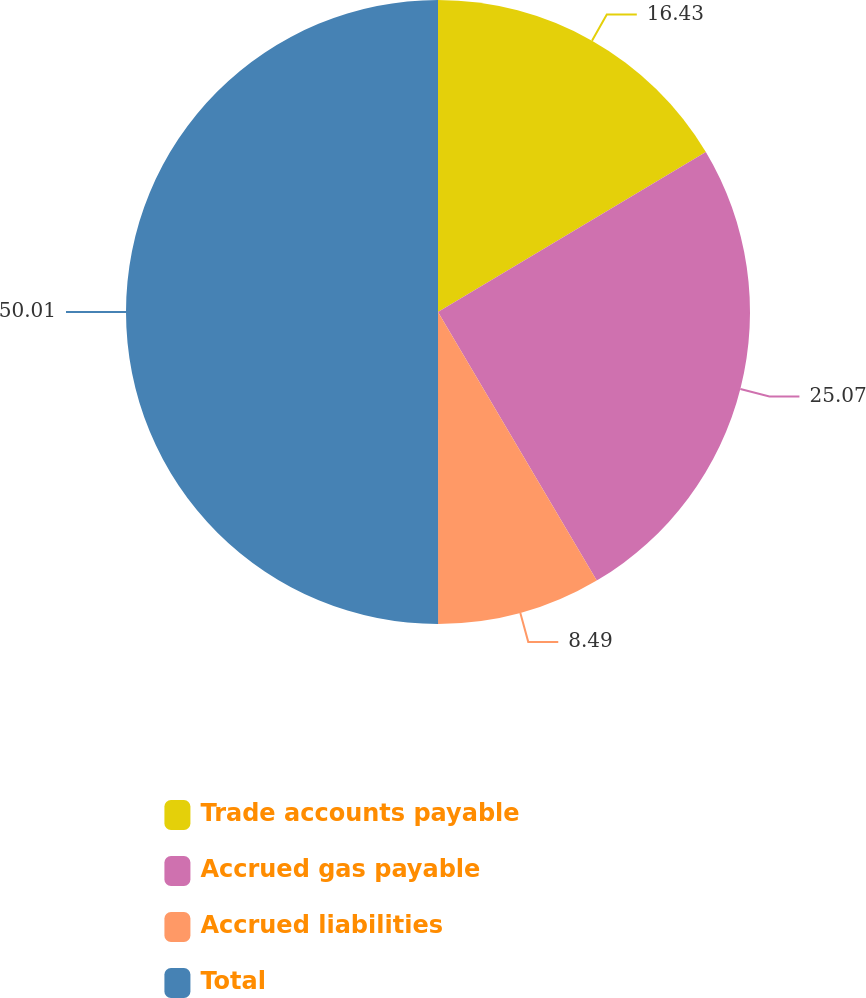Convert chart. <chart><loc_0><loc_0><loc_500><loc_500><pie_chart><fcel>Trade accounts payable<fcel>Accrued gas payable<fcel>Accrued liabilities<fcel>Total<nl><fcel>16.43%<fcel>25.07%<fcel>8.49%<fcel>50.0%<nl></chart> 